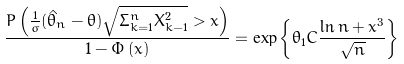Convert formula to latex. <formula><loc_0><loc_0><loc_500><loc_500>\frac { P \left ( \frac { 1 } { \sigma } ( \hat { \theta } _ { n } - \theta ) \sqrt { \Sigma _ { k = 1 } ^ { n } X _ { k - 1 } ^ { 2 } } > x \right ) } { 1 - \Phi \left ( x \right ) } = \exp \left \{ \theta _ { 1 } C \frac { \ln n + x ^ { 3 } } { \sqrt { n } } \right \}</formula> 